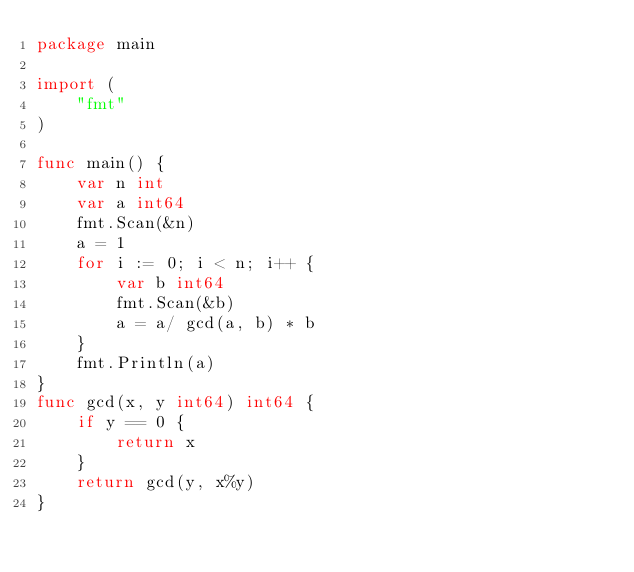<code> <loc_0><loc_0><loc_500><loc_500><_Go_>package main

import (
	"fmt"
)

func main() {
	var n int
    var a int64
	fmt.Scan(&n)
	a = 1
	for i := 0; i < n; i++ {
		var b int64
		fmt.Scan(&b)
		a = a/ gcd(a, b) * b
	}
	fmt.Println(a)
}
func gcd(x, y int64) int64 {
    if y == 0 {
        return x
    }
    return gcd(y, x%y)
}
</code> 